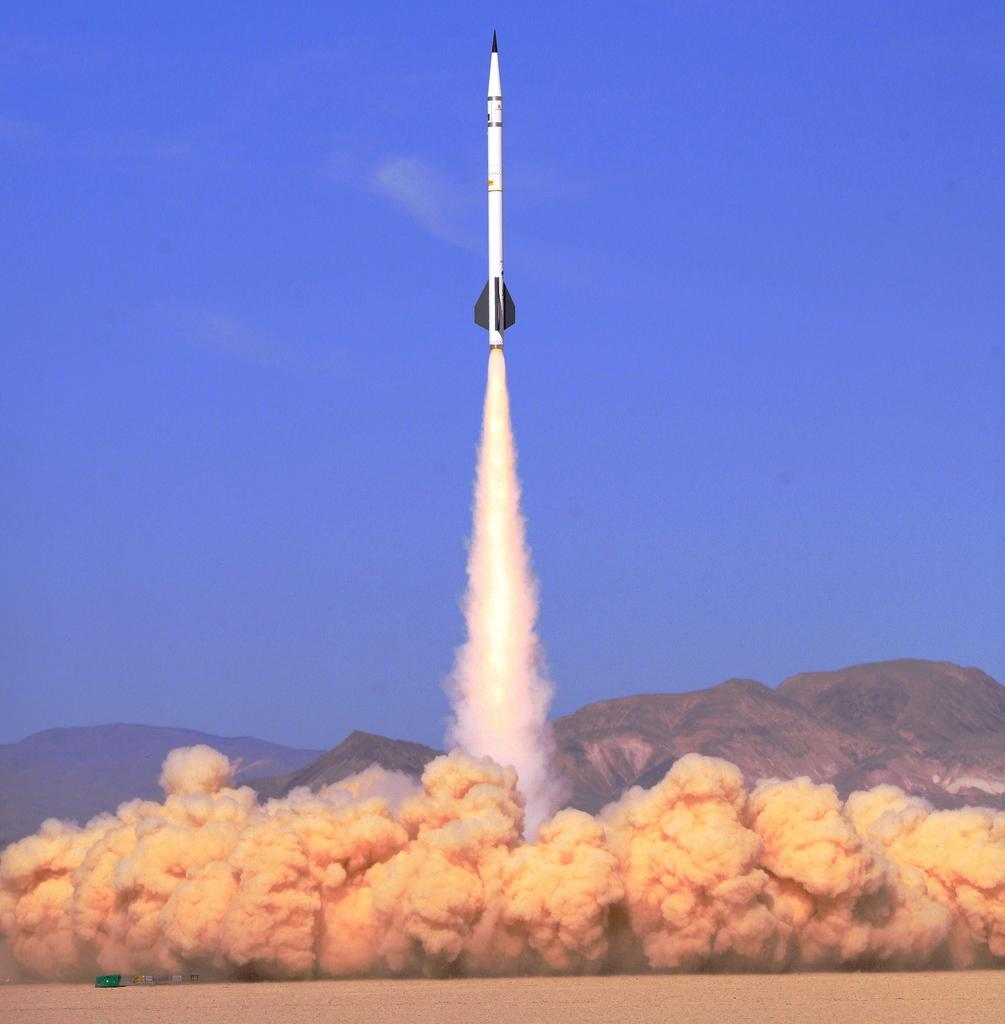What is the main subject of the image? The main subject of the image is a rocket. What is the rocket doing in the image? The rocket is flying in the image. What can be seen around the rocket in the image? There is a lot of smoke in the image. What type of natural feature is visible in the image? There is a mountain visible in the image. What type of celery can be seen growing on the mountain in the image? There is no celery present in the image, and celery does not grow on mountains. What is the rocket's hope for the future in the image? The image does not provide information about the rocket's hopes or future plans. 